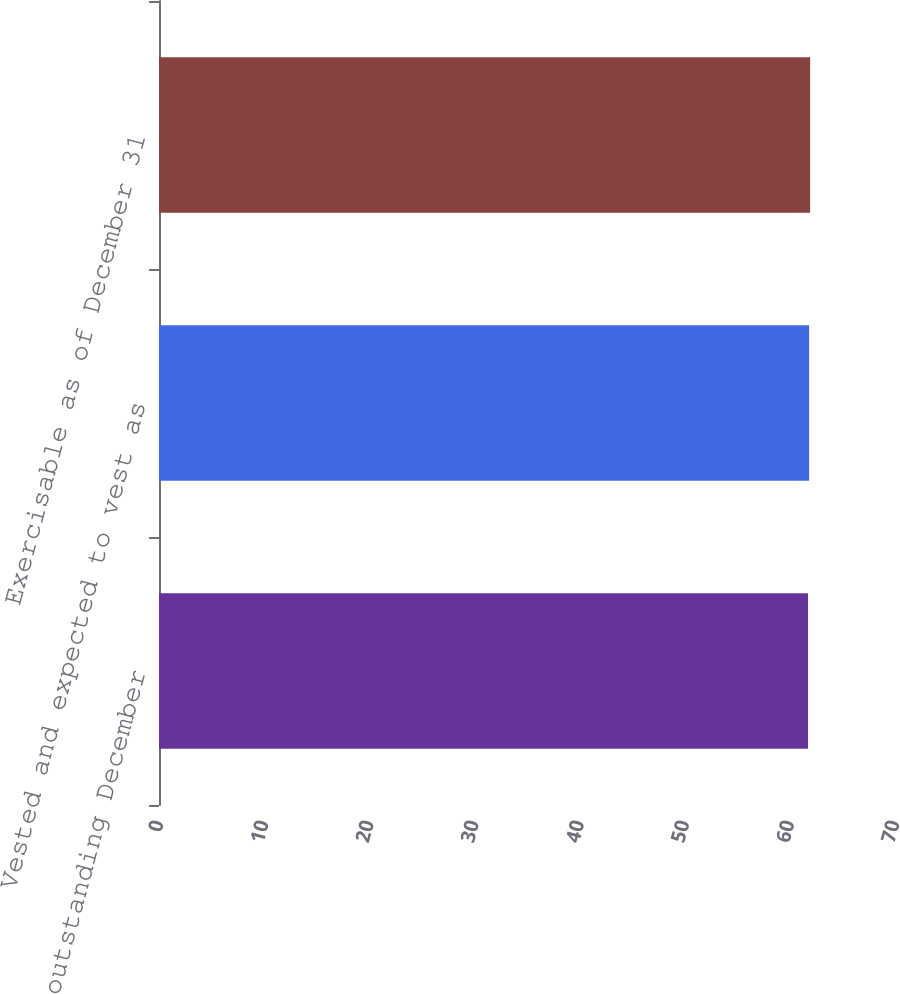<chart> <loc_0><loc_0><loc_500><loc_500><bar_chart><fcel>Options outstanding December<fcel>Vested and expected to vest as<fcel>Exercisable as of December 31<nl><fcel>61.73<fcel>61.83<fcel>61.93<nl></chart> 